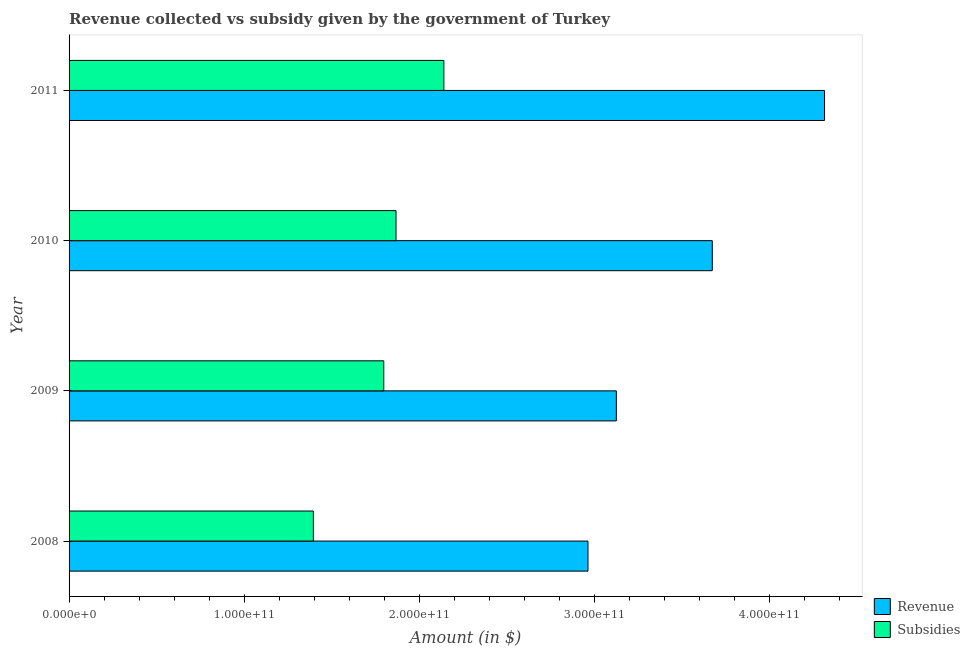How many different coloured bars are there?
Your answer should be very brief. 2. How many groups of bars are there?
Keep it short and to the point. 4. Are the number of bars per tick equal to the number of legend labels?
Offer a very short reply. Yes. Are the number of bars on each tick of the Y-axis equal?
Ensure brevity in your answer.  Yes. How many bars are there on the 4th tick from the top?
Your answer should be very brief. 2. What is the label of the 4th group of bars from the top?
Give a very brief answer. 2008. In how many cases, is the number of bars for a given year not equal to the number of legend labels?
Provide a short and direct response. 0. What is the amount of subsidies given in 2011?
Keep it short and to the point. 2.14e+11. Across all years, what is the maximum amount of revenue collected?
Your answer should be very brief. 4.31e+11. Across all years, what is the minimum amount of subsidies given?
Your response must be concise. 1.39e+11. What is the total amount of revenue collected in the graph?
Give a very brief answer. 1.41e+12. What is the difference between the amount of revenue collected in 2008 and that in 2009?
Your answer should be very brief. -1.62e+1. What is the difference between the amount of subsidies given in 2010 and the amount of revenue collected in 2011?
Offer a terse response. -2.45e+11. What is the average amount of subsidies given per year?
Provide a short and direct response. 1.80e+11. In the year 2011, what is the difference between the amount of revenue collected and amount of subsidies given?
Keep it short and to the point. 2.17e+11. In how many years, is the amount of revenue collected greater than 80000000000 $?
Provide a short and direct response. 4. What is the ratio of the amount of subsidies given in 2008 to that in 2011?
Ensure brevity in your answer.  0.65. Is the difference between the amount of revenue collected in 2008 and 2011 greater than the difference between the amount of subsidies given in 2008 and 2011?
Offer a very short reply. No. What is the difference between the highest and the second highest amount of subsidies given?
Your answer should be compact. 2.73e+1. What is the difference between the highest and the lowest amount of subsidies given?
Offer a very short reply. 7.45e+1. In how many years, is the amount of revenue collected greater than the average amount of revenue collected taken over all years?
Give a very brief answer. 2. What does the 1st bar from the top in 2011 represents?
Ensure brevity in your answer.  Subsidies. What does the 1st bar from the bottom in 2011 represents?
Your answer should be compact. Revenue. How many bars are there?
Offer a terse response. 8. What is the difference between two consecutive major ticks on the X-axis?
Provide a succinct answer. 1.00e+11. Does the graph contain grids?
Your answer should be compact. No. What is the title of the graph?
Your response must be concise. Revenue collected vs subsidy given by the government of Turkey. What is the label or title of the X-axis?
Give a very brief answer. Amount (in $). What is the label or title of the Y-axis?
Keep it short and to the point. Year. What is the Amount (in $) of Revenue in 2008?
Your response must be concise. 2.96e+11. What is the Amount (in $) of Subsidies in 2008?
Ensure brevity in your answer.  1.39e+11. What is the Amount (in $) of Revenue in 2009?
Offer a very short reply. 3.12e+11. What is the Amount (in $) of Subsidies in 2009?
Ensure brevity in your answer.  1.80e+11. What is the Amount (in $) of Revenue in 2010?
Keep it short and to the point. 3.67e+11. What is the Amount (in $) of Subsidies in 2010?
Make the answer very short. 1.87e+11. What is the Amount (in $) in Revenue in 2011?
Your response must be concise. 4.31e+11. What is the Amount (in $) in Subsidies in 2011?
Make the answer very short. 2.14e+11. Across all years, what is the maximum Amount (in $) in Revenue?
Your answer should be very brief. 4.31e+11. Across all years, what is the maximum Amount (in $) of Subsidies?
Keep it short and to the point. 2.14e+11. Across all years, what is the minimum Amount (in $) of Revenue?
Make the answer very short. 2.96e+11. Across all years, what is the minimum Amount (in $) of Subsidies?
Your answer should be very brief. 1.39e+11. What is the total Amount (in $) of Revenue in the graph?
Keep it short and to the point. 1.41e+12. What is the total Amount (in $) of Subsidies in the graph?
Provide a succinct answer. 7.20e+11. What is the difference between the Amount (in $) of Revenue in 2008 and that in 2009?
Make the answer very short. -1.62e+1. What is the difference between the Amount (in $) of Subsidies in 2008 and that in 2009?
Offer a terse response. -4.02e+1. What is the difference between the Amount (in $) of Revenue in 2008 and that in 2010?
Offer a terse response. -7.10e+1. What is the difference between the Amount (in $) in Subsidies in 2008 and that in 2010?
Provide a succinct answer. -4.72e+1. What is the difference between the Amount (in $) of Revenue in 2008 and that in 2011?
Provide a succinct answer. -1.35e+11. What is the difference between the Amount (in $) of Subsidies in 2008 and that in 2011?
Ensure brevity in your answer.  -7.45e+1. What is the difference between the Amount (in $) of Revenue in 2009 and that in 2010?
Offer a terse response. -5.48e+1. What is the difference between the Amount (in $) in Subsidies in 2009 and that in 2010?
Your answer should be very brief. -6.99e+09. What is the difference between the Amount (in $) in Revenue in 2009 and that in 2011?
Make the answer very short. -1.19e+11. What is the difference between the Amount (in $) of Subsidies in 2009 and that in 2011?
Ensure brevity in your answer.  -3.43e+1. What is the difference between the Amount (in $) in Revenue in 2010 and that in 2011?
Provide a succinct answer. -6.41e+1. What is the difference between the Amount (in $) in Subsidies in 2010 and that in 2011?
Offer a very short reply. -2.73e+1. What is the difference between the Amount (in $) of Revenue in 2008 and the Amount (in $) of Subsidies in 2009?
Give a very brief answer. 1.17e+11. What is the difference between the Amount (in $) in Revenue in 2008 and the Amount (in $) in Subsidies in 2010?
Provide a succinct answer. 1.10e+11. What is the difference between the Amount (in $) in Revenue in 2008 and the Amount (in $) in Subsidies in 2011?
Your answer should be very brief. 8.23e+1. What is the difference between the Amount (in $) of Revenue in 2009 and the Amount (in $) of Subsidies in 2010?
Your answer should be compact. 1.26e+11. What is the difference between the Amount (in $) in Revenue in 2009 and the Amount (in $) in Subsidies in 2011?
Your answer should be very brief. 9.85e+1. What is the difference between the Amount (in $) in Revenue in 2010 and the Amount (in $) in Subsidies in 2011?
Provide a short and direct response. 1.53e+11. What is the average Amount (in $) in Revenue per year?
Make the answer very short. 3.52e+11. What is the average Amount (in $) of Subsidies per year?
Offer a very short reply. 1.80e+11. In the year 2008, what is the difference between the Amount (in $) in Revenue and Amount (in $) in Subsidies?
Provide a short and direct response. 1.57e+11. In the year 2009, what is the difference between the Amount (in $) of Revenue and Amount (in $) of Subsidies?
Ensure brevity in your answer.  1.33e+11. In the year 2010, what is the difference between the Amount (in $) of Revenue and Amount (in $) of Subsidies?
Keep it short and to the point. 1.81e+11. In the year 2011, what is the difference between the Amount (in $) in Revenue and Amount (in $) in Subsidies?
Your answer should be very brief. 2.17e+11. What is the ratio of the Amount (in $) in Revenue in 2008 to that in 2009?
Your answer should be very brief. 0.95. What is the ratio of the Amount (in $) in Subsidies in 2008 to that in 2009?
Your answer should be compact. 0.78. What is the ratio of the Amount (in $) of Revenue in 2008 to that in 2010?
Offer a terse response. 0.81. What is the ratio of the Amount (in $) of Subsidies in 2008 to that in 2010?
Keep it short and to the point. 0.75. What is the ratio of the Amount (in $) in Revenue in 2008 to that in 2011?
Ensure brevity in your answer.  0.69. What is the ratio of the Amount (in $) of Subsidies in 2008 to that in 2011?
Your answer should be very brief. 0.65. What is the ratio of the Amount (in $) of Revenue in 2009 to that in 2010?
Ensure brevity in your answer.  0.85. What is the ratio of the Amount (in $) in Subsidies in 2009 to that in 2010?
Make the answer very short. 0.96. What is the ratio of the Amount (in $) in Revenue in 2009 to that in 2011?
Keep it short and to the point. 0.72. What is the ratio of the Amount (in $) of Subsidies in 2009 to that in 2011?
Keep it short and to the point. 0.84. What is the ratio of the Amount (in $) in Revenue in 2010 to that in 2011?
Offer a very short reply. 0.85. What is the ratio of the Amount (in $) in Subsidies in 2010 to that in 2011?
Offer a very short reply. 0.87. What is the difference between the highest and the second highest Amount (in $) in Revenue?
Provide a short and direct response. 6.41e+1. What is the difference between the highest and the second highest Amount (in $) in Subsidies?
Your answer should be compact. 2.73e+1. What is the difference between the highest and the lowest Amount (in $) of Revenue?
Provide a short and direct response. 1.35e+11. What is the difference between the highest and the lowest Amount (in $) of Subsidies?
Provide a short and direct response. 7.45e+1. 